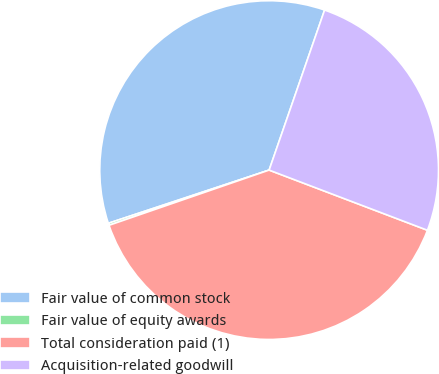Convert chart to OTSL. <chart><loc_0><loc_0><loc_500><loc_500><pie_chart><fcel>Fair value of common stock<fcel>Fair value of equity awards<fcel>Total consideration paid (1)<fcel>Acquisition-related goodwill<nl><fcel>35.39%<fcel>0.2%<fcel>38.93%<fcel>25.47%<nl></chart> 